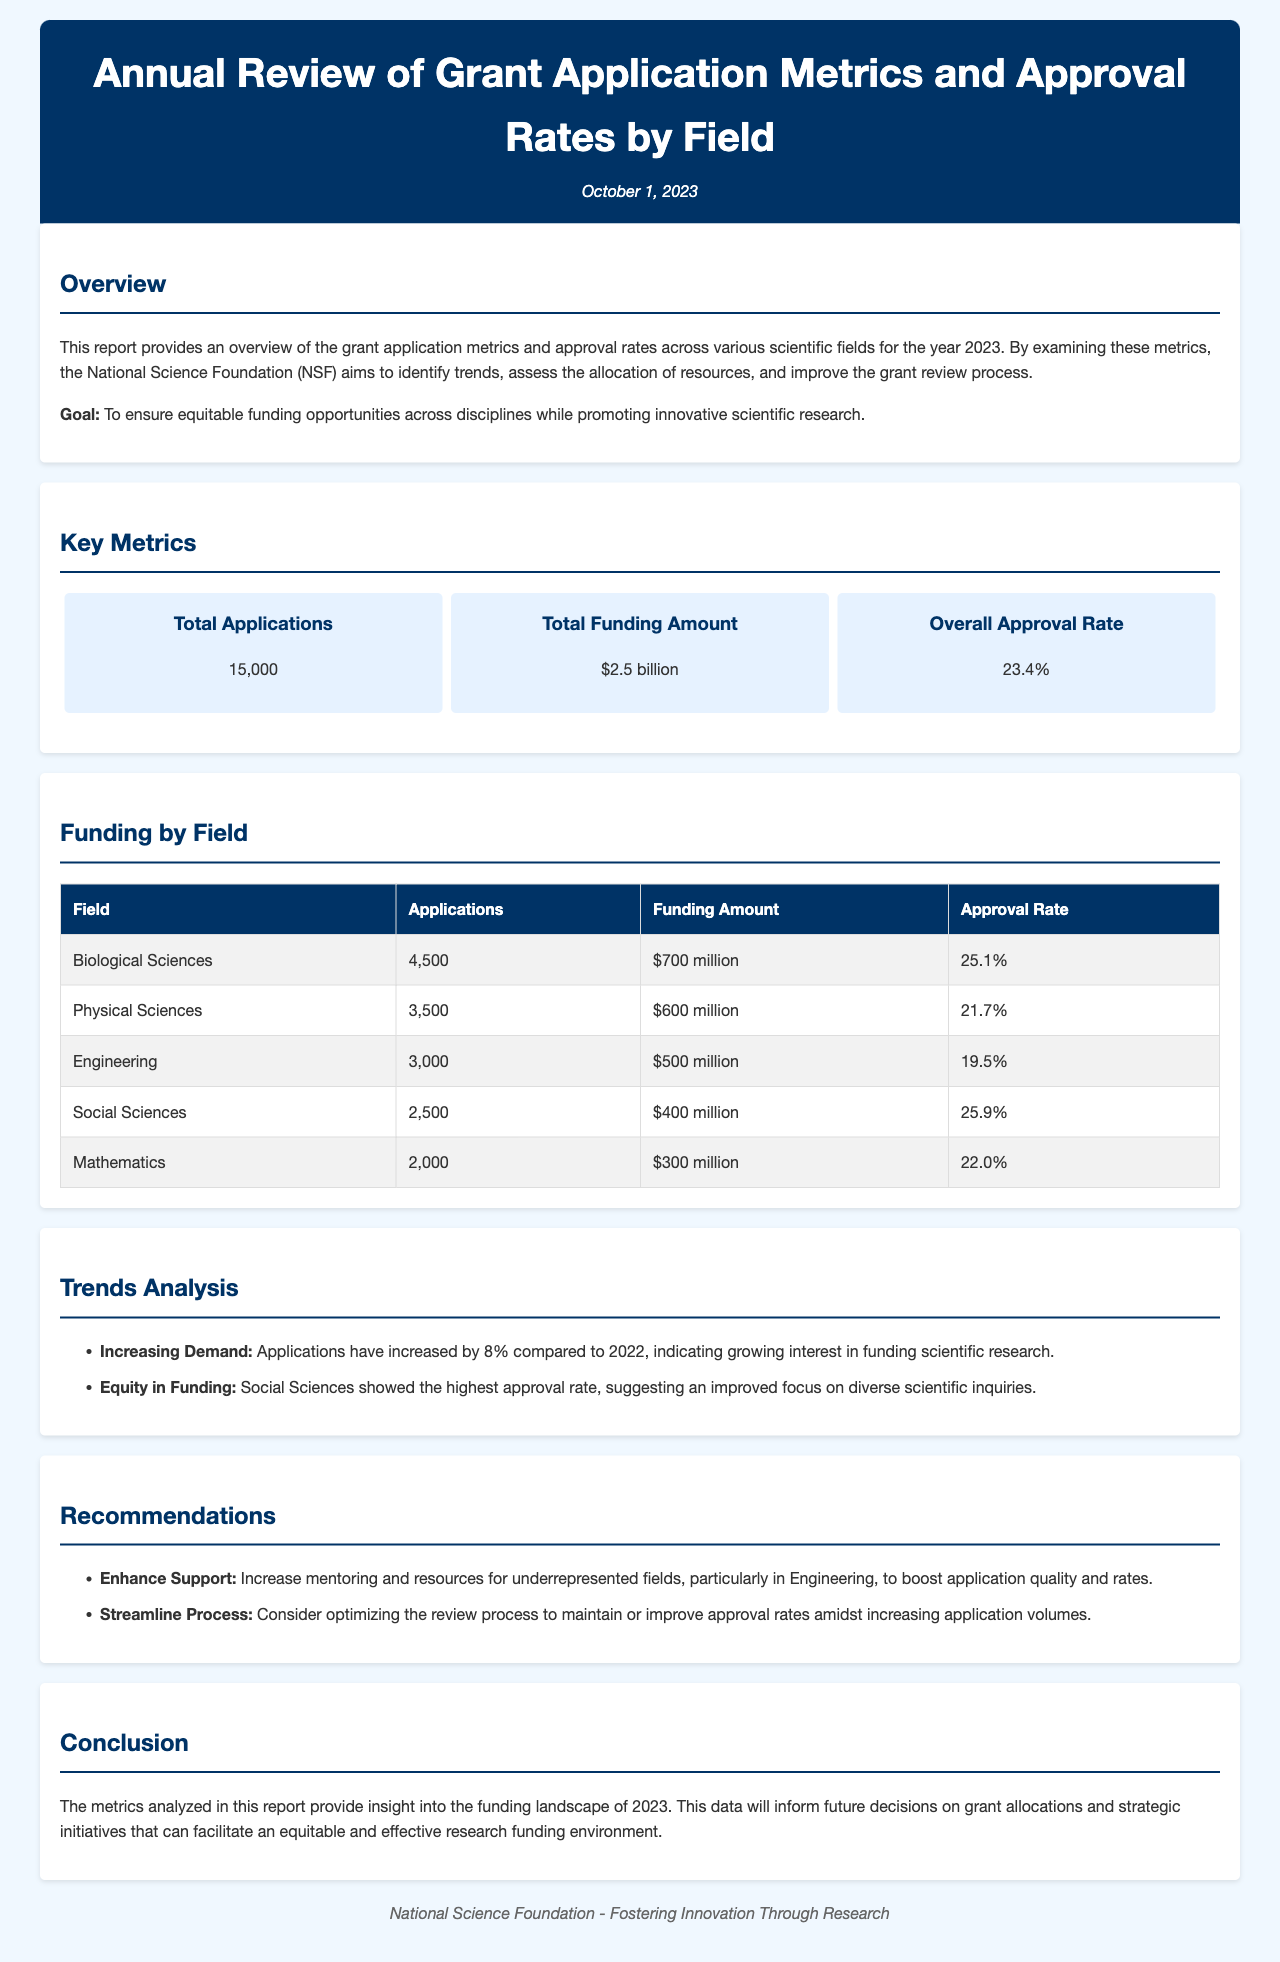What is the total number of applications? The total number of applications is specified in the key metrics section of the document, which is 15,000.
Answer: 15,000 What is the total funding amount? The total funding amount is listed in the key metrics section, which is $2.5 billion.
Answer: $2.5 billion Which field received the highest funding amount? The field that received the highest funding amount is indicated in the funding by field section, which is Biological Sciences.
Answer: Biological Sciences What is the approval rate for Social Sciences? The approval rate for Social Sciences can be found in the funding by field table, which shows 25.9%.
Answer: 25.9% What was the percentage increase in applications compared to 2022? The percentage increase in applications is mentioned in the trends analysis section, which states an increase of 8%.
Answer: 8% Which field showed the highest approval rate? The field with the highest approval rate is noted in the trends analysis section, which is Social Sciences.
Answer: Social Sciences What is one recommendation made in the report? One of the recommendations can be found in the recommendations section, which states to increase mentoring and resources for underrepresented fields.
Answer: Increase mentoring and resources When was this report published? The publication date is provided in the header section of the document, which is October 1, 2023.
Answer: October 1, 2023 What is the overall approval rate? The overall approval rate is detailed in the key metrics section and is stated as 23.4%.
Answer: 23.4% How many applications were submitted in the Engineering field? The number of applications submitted in the Engineering field is given in the funding by field table, which is 3,000.
Answer: 3,000 